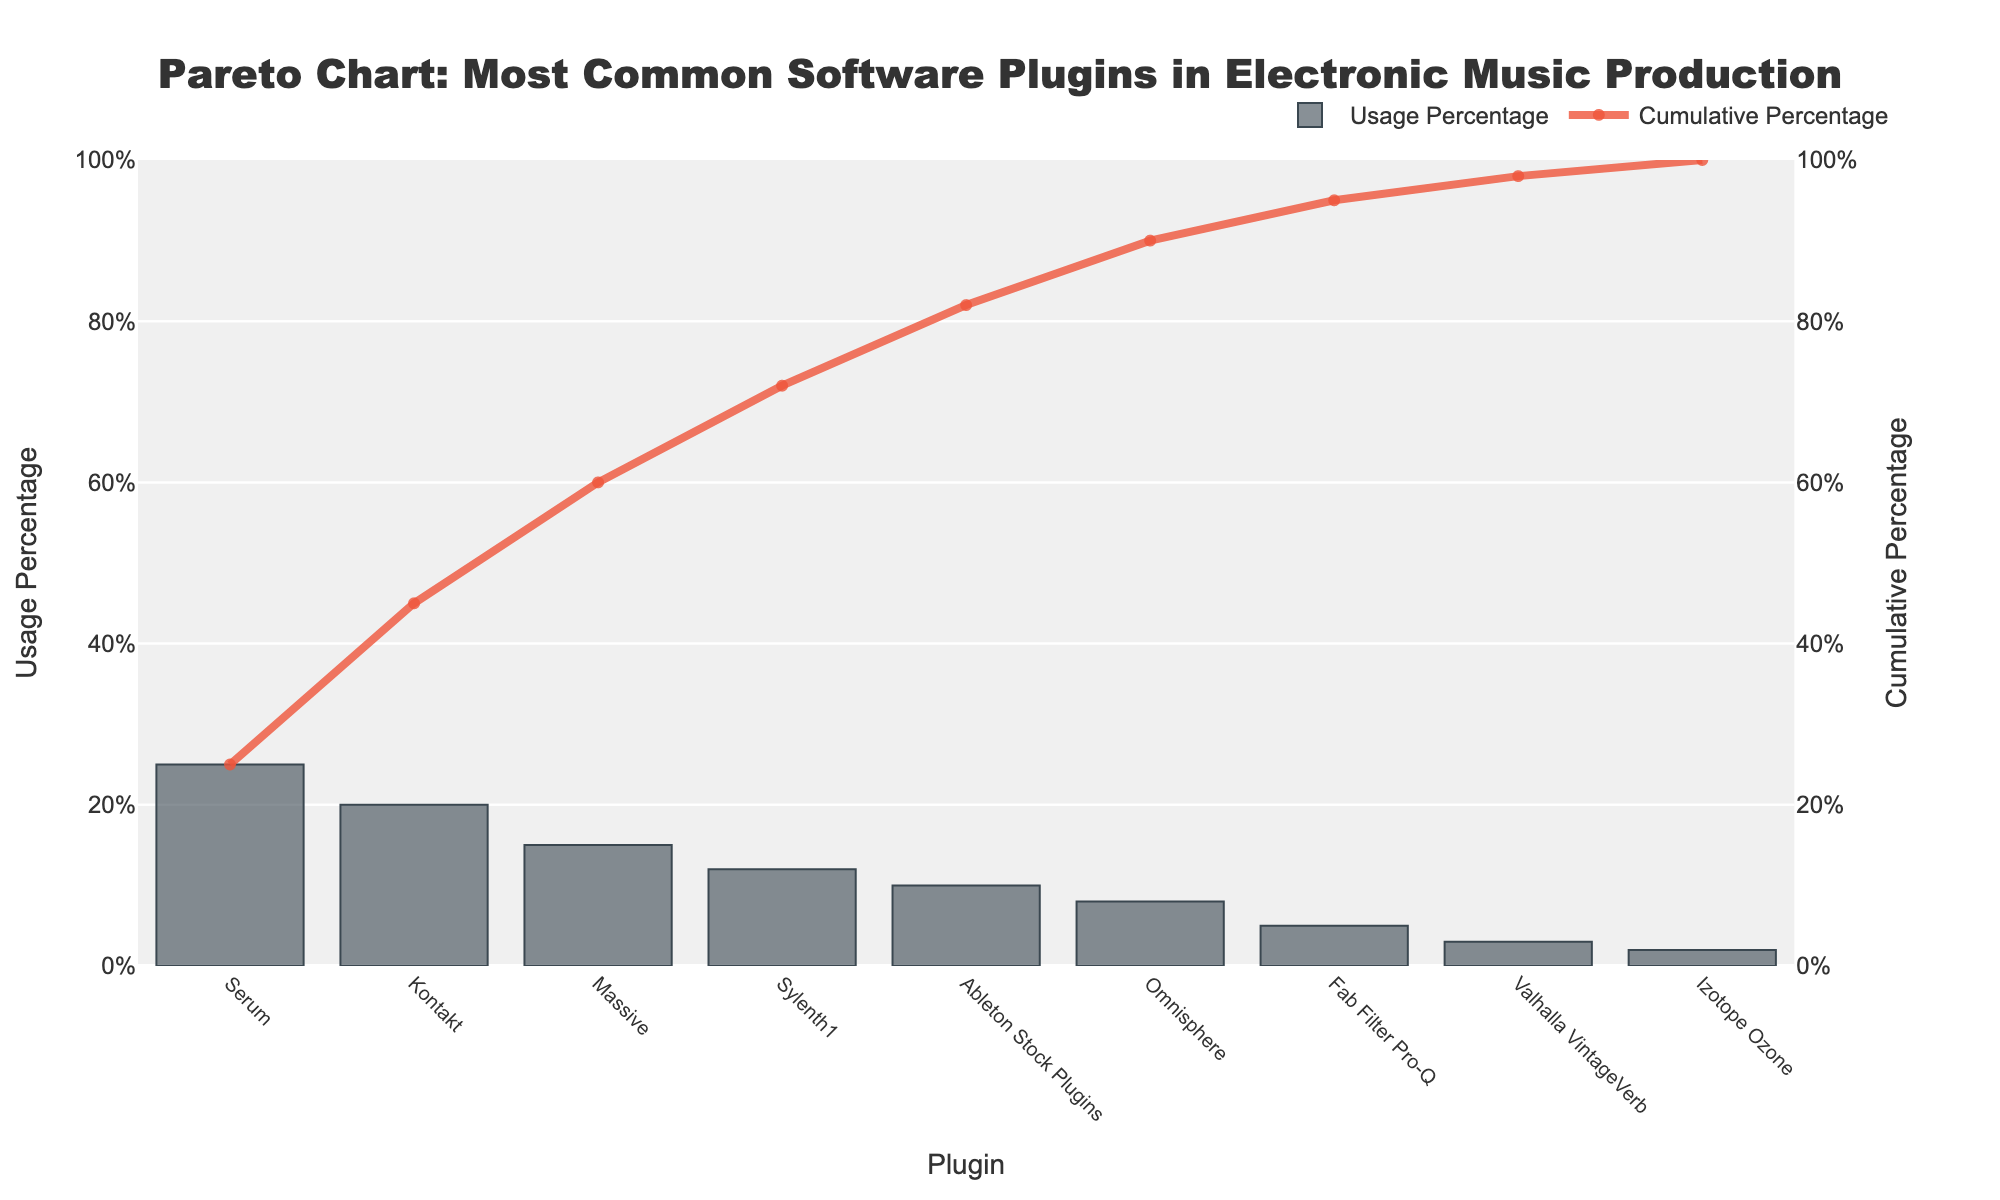What's the most commonly used plugin in electronic music production according to the chart? The chart shows the plugins ranked by usage percentage, with the highest bar indicating the most commonly used. Serum has the highest usage percentage at 25%.
Answer: Serum What's the cumulative percentage of the top three plugins? The cumulative percentage is indicated by the line trace on the chart. The top three plugins (Serum, Kontakt, and Massive) have cumulative percentages of 25%, 45%, and 60%, respectively.
Answer: 60% Which plugin ranks fifth in terms of usage percentage? By counting the bars from left to right according to their height, the fifth bar corresponds to Ableton Stock Plugins.
Answer: Ableton Stock Plugins How does the usage percentage of Sylenth1 compare to that of Omnisphere? Sylenth1 has a usage percentage of 12%, while Omnisphere has 8%. Sylenth1's usage percentage is higher.
Answer: Sylenth1's usage percentage is higher What's the cumulative percentage after including the first six plugins? The line trace on the chart shows the cumulative percentage. The first six plugins (Serum, Kontakt, Massive, Sylenth1, Ableton Stock Plugins, and Omnisphere) add up to a cumulative percentage of 90%.
Answer: 90% What is the total percentage of usage covered by the least common three plugins? The least common three plugins are Valhalla VintageVerb, Izotope Ozone, and Fab Filter Pro-Q, with usage percentages of 3%, 2%, and 5% respectively. Adding these up gives a total of 10%.
Answer: 10% What is the difference in usage percentage between the most and least common plugin? Serum has the highest usage percentage at 25%, and Izotope Ozone has the lowest at 2%. The difference is 25% - 2% = 23%.
Answer: 23% At what usage percentage does the cumulative percentage reach 50%? The cumulative percentage reaches 50% between the third plugin Massive (45%) and the fourth plugin Sylenth1 (57%).
Answer: Between 45% and 57% What is the combined usage percentage of the plugins ranked 2nd, 3rd, and 4th? Kontakt (20%), Massive (15%), and Sylenth1 (12%) are ranked 2nd, 3rd, and 4th, respectively. Their combined usage percentage is 20% + 15% + 12% = 47%.
Answer: 47% How many plugins have a usage percentage below 10%? Plugins with usage percentages below 10% are Omnisphere (8%), Fab Filter Pro-Q (5%), Valhalla VintageVerb (3%), and Izotope Ozone (2%). There are 4 such plugins.
Answer: 4 